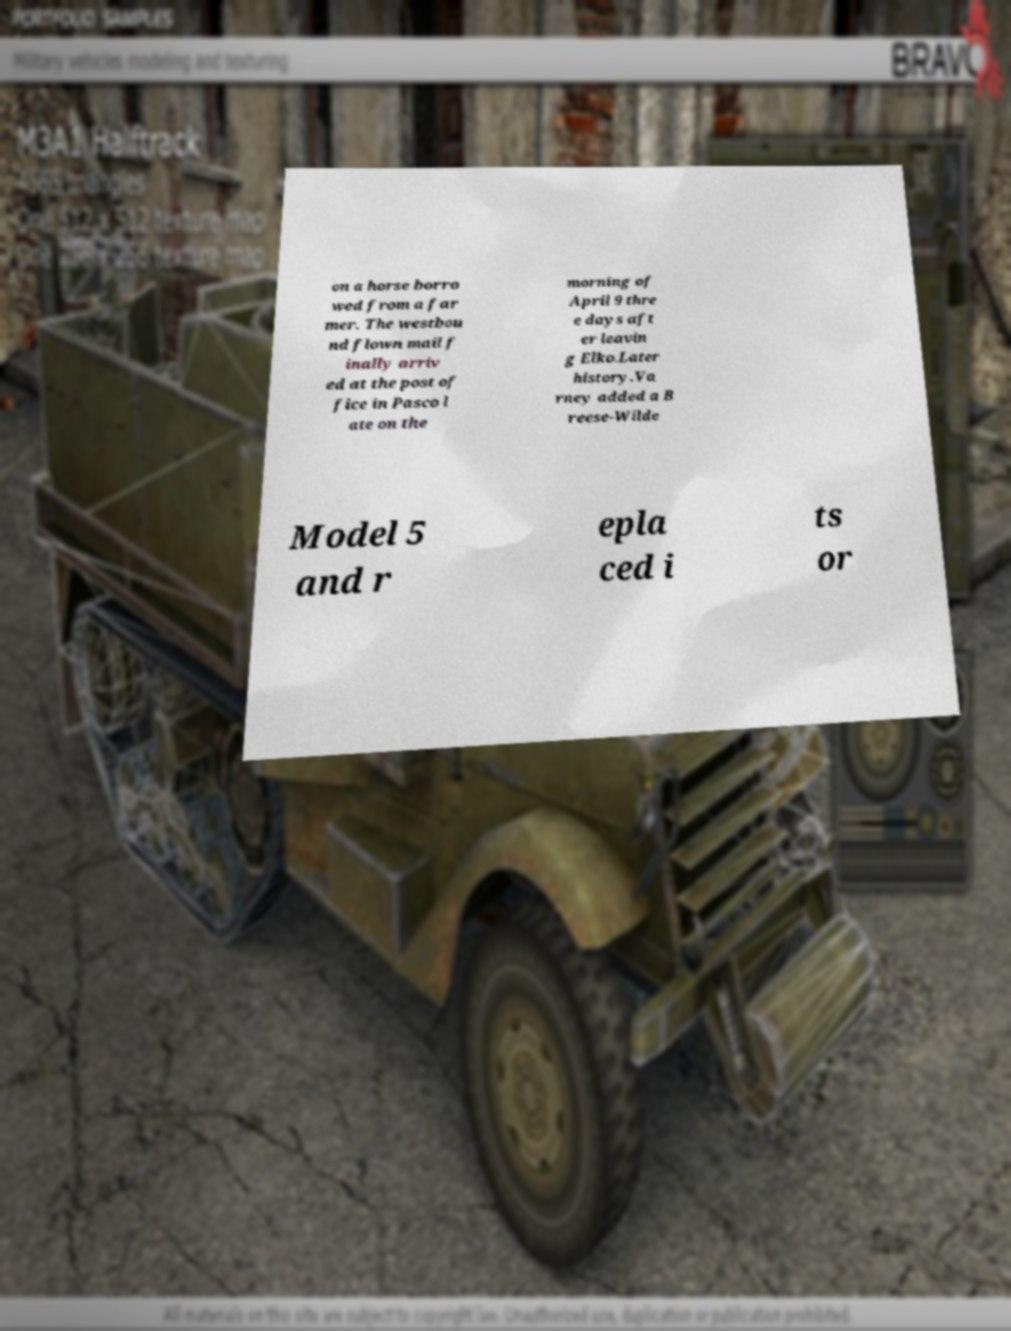Please read and relay the text visible in this image. What does it say? on a horse borro wed from a far mer. The westbou nd flown mail f inally arriv ed at the post of fice in Pasco l ate on the morning of April 9 thre e days aft er leavin g Elko.Later history.Va rney added a B reese-Wilde Model 5 and r epla ced i ts or 